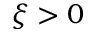<formula> <loc_0><loc_0><loc_500><loc_500>\xi > 0</formula> 